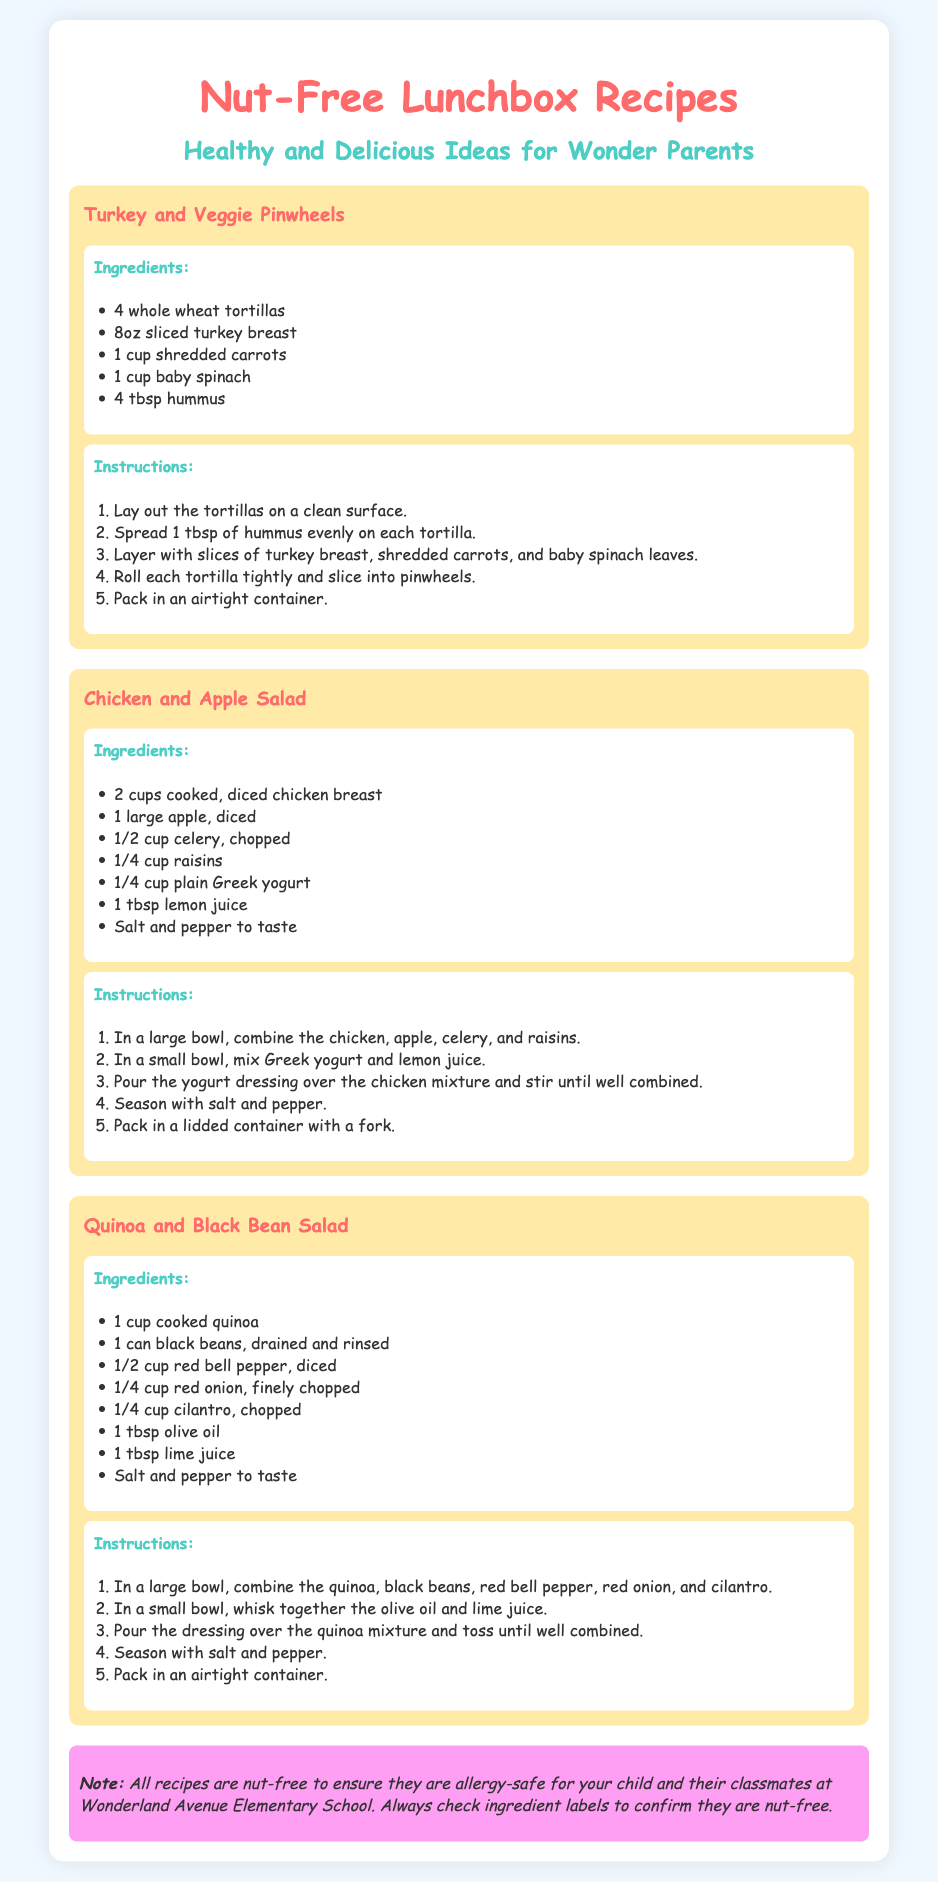What is the title of the document? The title of the document is presented at the top and indicates the key focus of the content, which is "Nut-Free Lunchbox Recipes".
Answer: Nut-Free Lunchbox Recipes How many recipes are included? There are three distinct recipes listed in the document, each with its own ingredients and instructions.
Answer: 3 What is the main ingredient in "Chicken and Apple Salad"? The primary ingredient mentioned at the top of this recipe is cooked, diced chicken breast, as it is the first item in the ingredients list.
Answer: Cooked chicken breast What should you check to ensure recipes are allergy-safe? The document advises checking ingredient labels to confirm that they are nut-free, particularly to avoid allergies in children.
Answer: Ingredient labels What is the cooking method for "Quinoa and Black Bean Salad"? The instructions for this salad indicate no actual cooking but rather a mixing of ingredients, categorizing it as a cold salad preparation.
Answer: No cooking required How many tortillas are needed for "Turkey and Veggie Pinwheels"? The number of whole wheat tortillas required for this recipe is explicitly stated in the ingredients section.
Answer: 4 What color is the background of the document? The background color of the document is specified in the CSS styles, enhancing the visual appearance for readability.
Answer: Light blue Which vegetable is used in the "Quinoa and Black Bean Salad"? The recipe mentions red bell pepper as one of the key vegetables, highlighting its inclusion in the ingredients list.
Answer: Red bell pepper 